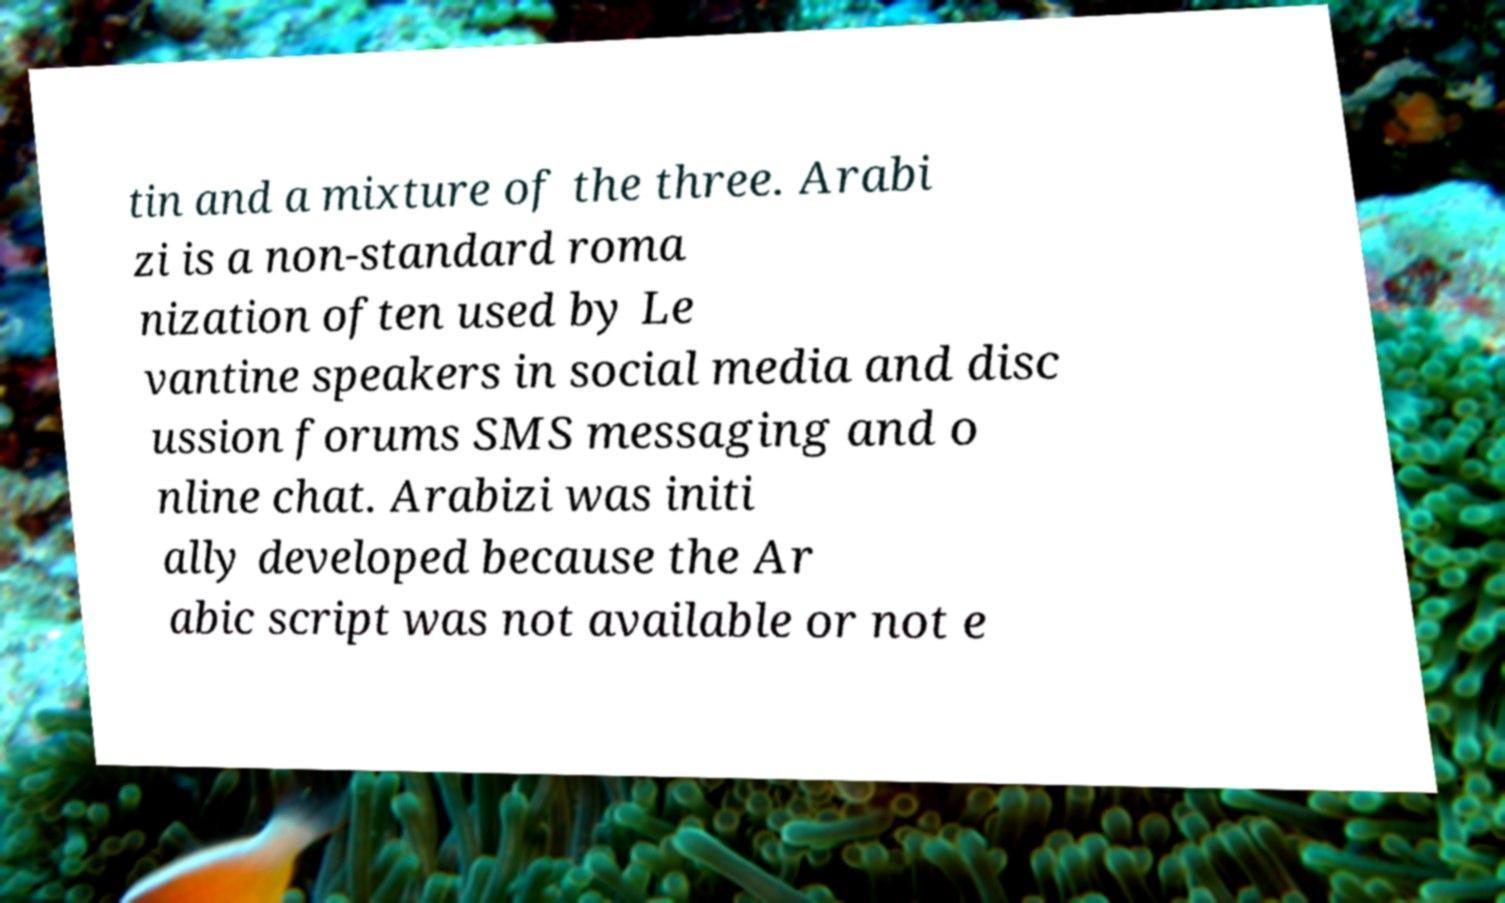Could you assist in decoding the text presented in this image and type it out clearly? tin and a mixture of the three. Arabi zi is a non-standard roma nization often used by Le vantine speakers in social media and disc ussion forums SMS messaging and o nline chat. Arabizi was initi ally developed because the Ar abic script was not available or not e 